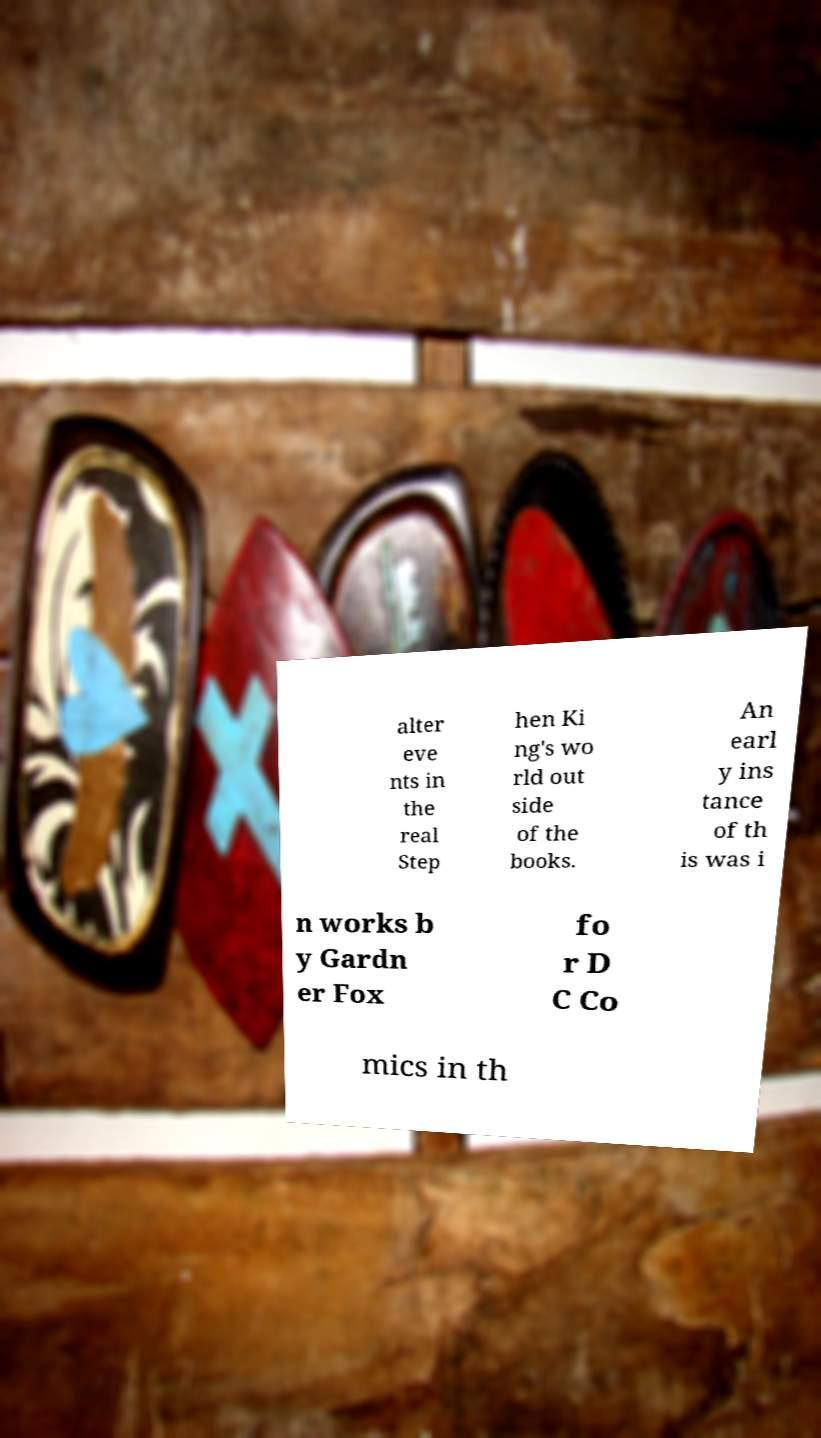What messages or text are displayed in this image? I need them in a readable, typed format. alter eve nts in the real Step hen Ki ng's wo rld out side of the books. An earl y ins tance of th is was i n works b y Gardn er Fox fo r D C Co mics in th 